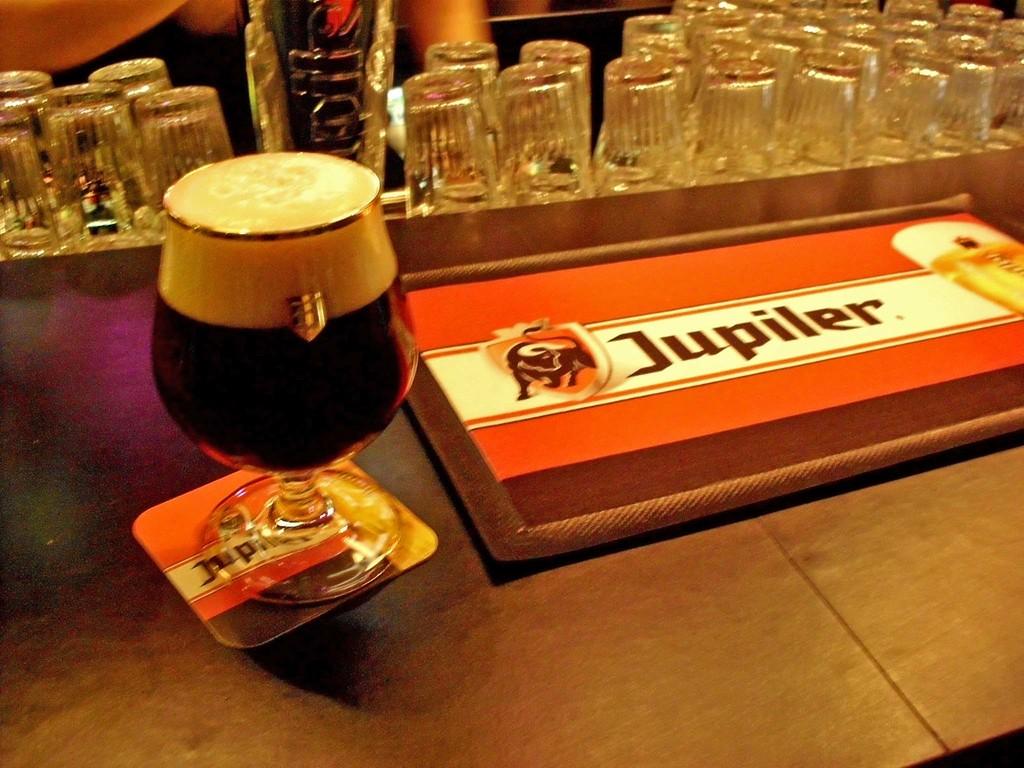What is the name of this beer?
Give a very brief answer. Jupiler. How many letters are in the name?
Provide a short and direct response. 7. 